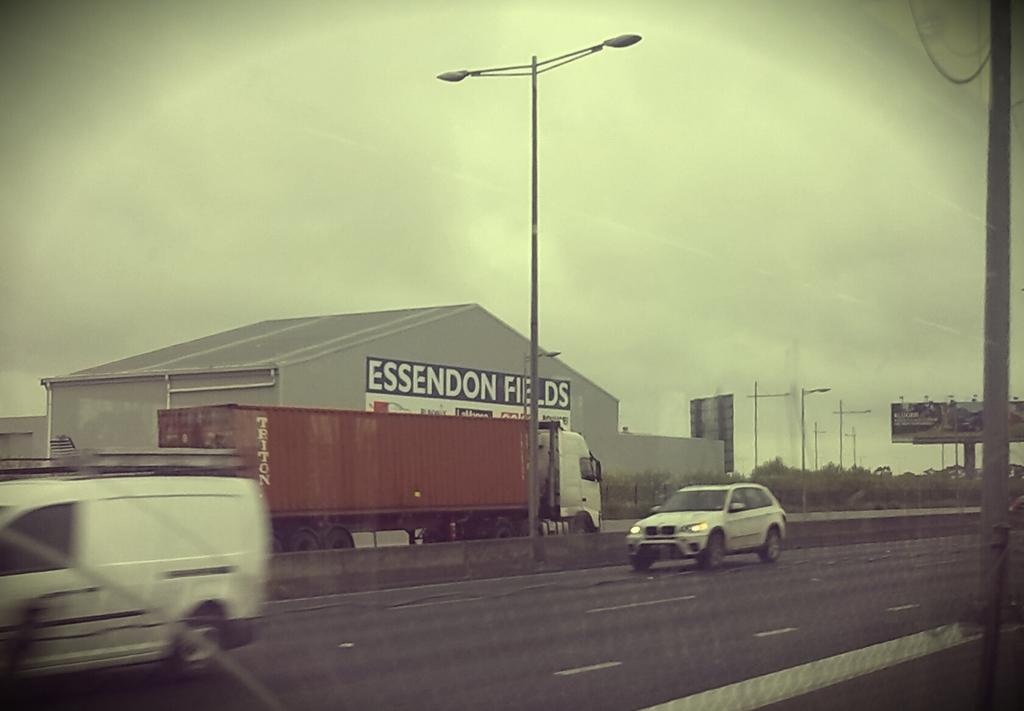What is happening in the image? There are vehicles moving in the image. What can be seen in the distance in the image? There are buildings in the background of the image. How would you describe the weather in the image? The sky is clear in the image, suggesting good weather. What type of record is being played in the image? There is no record present in the image; it features moving vehicles and buildings in the background. Is the cat in the image feeling healthy? There is no cat present in the image. 